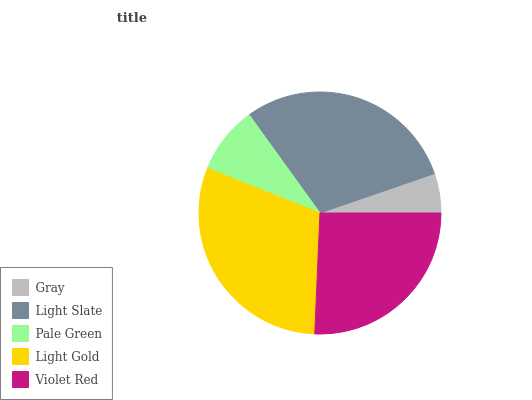Is Gray the minimum?
Answer yes or no. Yes. Is Light Gold the maximum?
Answer yes or no. Yes. Is Light Slate the minimum?
Answer yes or no. No. Is Light Slate the maximum?
Answer yes or no. No. Is Light Slate greater than Gray?
Answer yes or no. Yes. Is Gray less than Light Slate?
Answer yes or no. Yes. Is Gray greater than Light Slate?
Answer yes or no. No. Is Light Slate less than Gray?
Answer yes or no. No. Is Violet Red the high median?
Answer yes or no. Yes. Is Violet Red the low median?
Answer yes or no. Yes. Is Light Gold the high median?
Answer yes or no. No. Is Pale Green the low median?
Answer yes or no. No. 